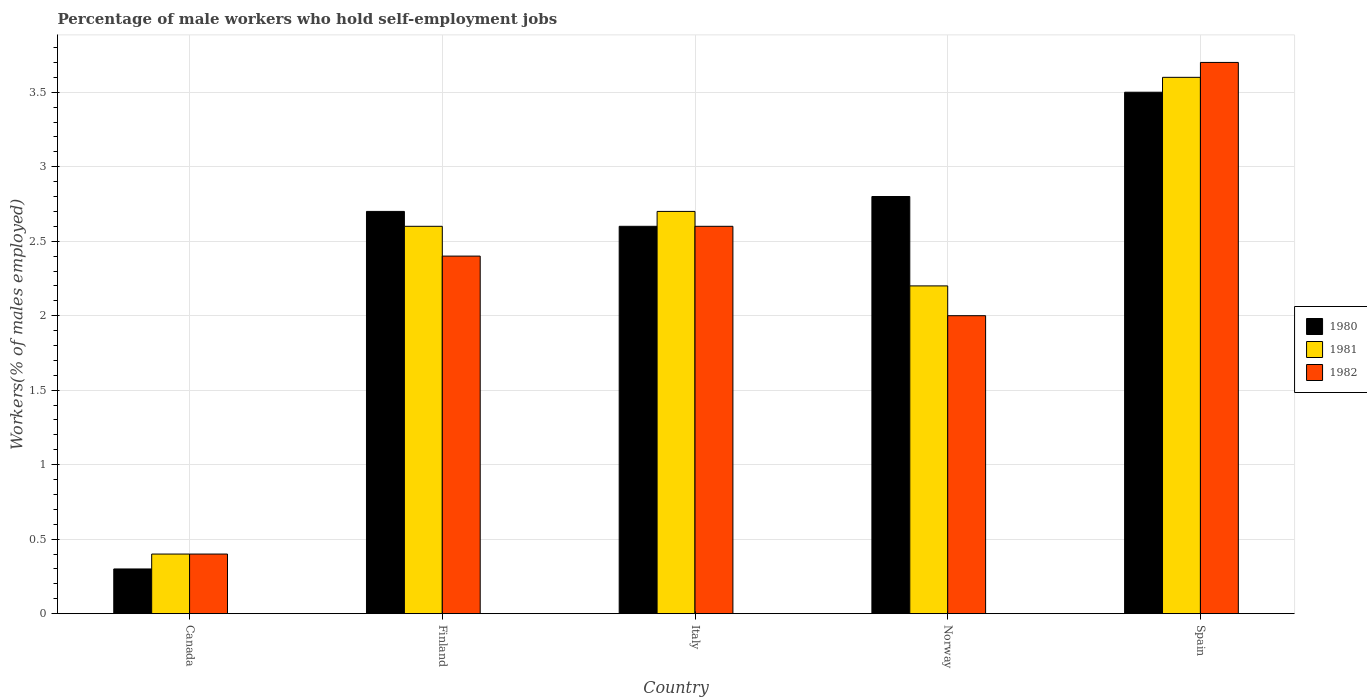How many different coloured bars are there?
Ensure brevity in your answer.  3. How many groups of bars are there?
Your answer should be very brief. 5. Are the number of bars on each tick of the X-axis equal?
Offer a very short reply. Yes. How many bars are there on the 2nd tick from the left?
Keep it short and to the point. 3. How many bars are there on the 4th tick from the right?
Your answer should be compact. 3. What is the label of the 5th group of bars from the left?
Make the answer very short. Spain. What is the percentage of self-employed male workers in 1980 in Canada?
Provide a succinct answer. 0.3. Across all countries, what is the minimum percentage of self-employed male workers in 1981?
Your answer should be very brief. 0.4. In which country was the percentage of self-employed male workers in 1981 maximum?
Your response must be concise. Spain. In which country was the percentage of self-employed male workers in 1982 minimum?
Your answer should be compact. Canada. What is the total percentage of self-employed male workers in 1980 in the graph?
Offer a terse response. 11.9. What is the difference between the percentage of self-employed male workers in 1981 in Canada and that in Finland?
Make the answer very short. -2.2. What is the difference between the percentage of self-employed male workers in 1982 in Norway and the percentage of self-employed male workers in 1981 in Finland?
Provide a succinct answer. -0.6. What is the average percentage of self-employed male workers in 1980 per country?
Keep it short and to the point. 2.38. In how many countries, is the percentage of self-employed male workers in 1981 greater than 0.7 %?
Your answer should be very brief. 4. What is the ratio of the percentage of self-employed male workers in 1981 in Canada to that in Spain?
Your answer should be very brief. 0.11. What is the difference between the highest and the second highest percentage of self-employed male workers in 1981?
Make the answer very short. -0.9. What is the difference between the highest and the lowest percentage of self-employed male workers in 1980?
Offer a very short reply. 3.2. In how many countries, is the percentage of self-employed male workers in 1982 greater than the average percentage of self-employed male workers in 1982 taken over all countries?
Provide a succinct answer. 3. What does the 2nd bar from the left in Spain represents?
Make the answer very short. 1981. What is the difference between two consecutive major ticks on the Y-axis?
Keep it short and to the point. 0.5. Are the values on the major ticks of Y-axis written in scientific E-notation?
Your answer should be very brief. No. Does the graph contain any zero values?
Your response must be concise. No. Does the graph contain grids?
Give a very brief answer. Yes. Where does the legend appear in the graph?
Provide a succinct answer. Center right. How many legend labels are there?
Your answer should be very brief. 3. What is the title of the graph?
Your response must be concise. Percentage of male workers who hold self-employment jobs. Does "2010" appear as one of the legend labels in the graph?
Provide a short and direct response. No. What is the label or title of the X-axis?
Offer a terse response. Country. What is the label or title of the Y-axis?
Offer a terse response. Workers(% of males employed). What is the Workers(% of males employed) of 1980 in Canada?
Provide a short and direct response. 0.3. What is the Workers(% of males employed) of 1981 in Canada?
Your answer should be very brief. 0.4. What is the Workers(% of males employed) in 1982 in Canada?
Offer a very short reply. 0.4. What is the Workers(% of males employed) of 1980 in Finland?
Offer a terse response. 2.7. What is the Workers(% of males employed) of 1981 in Finland?
Your answer should be very brief. 2.6. What is the Workers(% of males employed) of 1982 in Finland?
Ensure brevity in your answer.  2.4. What is the Workers(% of males employed) of 1980 in Italy?
Provide a succinct answer. 2.6. What is the Workers(% of males employed) of 1981 in Italy?
Make the answer very short. 2.7. What is the Workers(% of males employed) in 1982 in Italy?
Your answer should be very brief. 2.6. What is the Workers(% of males employed) of 1980 in Norway?
Your response must be concise. 2.8. What is the Workers(% of males employed) of 1981 in Norway?
Ensure brevity in your answer.  2.2. What is the Workers(% of males employed) of 1982 in Norway?
Offer a terse response. 2. What is the Workers(% of males employed) in 1980 in Spain?
Your answer should be very brief. 3.5. What is the Workers(% of males employed) in 1981 in Spain?
Your answer should be very brief. 3.6. What is the Workers(% of males employed) of 1982 in Spain?
Keep it short and to the point. 3.7. Across all countries, what is the maximum Workers(% of males employed) of 1981?
Keep it short and to the point. 3.6. Across all countries, what is the maximum Workers(% of males employed) of 1982?
Your response must be concise. 3.7. Across all countries, what is the minimum Workers(% of males employed) of 1980?
Give a very brief answer. 0.3. Across all countries, what is the minimum Workers(% of males employed) of 1981?
Provide a succinct answer. 0.4. Across all countries, what is the minimum Workers(% of males employed) of 1982?
Your response must be concise. 0.4. What is the total Workers(% of males employed) of 1981 in the graph?
Keep it short and to the point. 11.5. What is the difference between the Workers(% of males employed) in 1981 in Canada and that in Finland?
Your response must be concise. -2.2. What is the difference between the Workers(% of males employed) in 1982 in Canada and that in Norway?
Your answer should be very brief. -1.6. What is the difference between the Workers(% of males employed) in 1980 in Canada and that in Spain?
Give a very brief answer. -3.2. What is the difference between the Workers(% of males employed) in 1982 in Canada and that in Spain?
Offer a very short reply. -3.3. What is the difference between the Workers(% of males employed) in 1980 in Finland and that in Italy?
Give a very brief answer. 0.1. What is the difference between the Workers(% of males employed) of 1981 in Finland and that in Norway?
Your answer should be compact. 0.4. What is the difference between the Workers(% of males employed) in 1982 in Finland and that in Norway?
Your response must be concise. 0.4. What is the difference between the Workers(% of males employed) in 1980 in Finland and that in Spain?
Ensure brevity in your answer.  -0.8. What is the difference between the Workers(% of males employed) in 1981 in Finland and that in Spain?
Ensure brevity in your answer.  -1. What is the difference between the Workers(% of males employed) of 1982 in Finland and that in Spain?
Provide a short and direct response. -1.3. What is the difference between the Workers(% of males employed) in 1980 in Italy and that in Norway?
Offer a very short reply. -0.2. What is the difference between the Workers(% of males employed) of 1980 in Italy and that in Spain?
Ensure brevity in your answer.  -0.9. What is the difference between the Workers(% of males employed) in 1981 in Italy and that in Spain?
Your response must be concise. -0.9. What is the difference between the Workers(% of males employed) of 1982 in Italy and that in Spain?
Your answer should be very brief. -1.1. What is the difference between the Workers(% of males employed) in 1980 in Canada and the Workers(% of males employed) in 1981 in Finland?
Give a very brief answer. -2.3. What is the difference between the Workers(% of males employed) in 1980 in Canada and the Workers(% of males employed) in 1982 in Finland?
Your answer should be compact. -2.1. What is the difference between the Workers(% of males employed) of 1980 in Canada and the Workers(% of males employed) of 1981 in Italy?
Offer a very short reply. -2.4. What is the difference between the Workers(% of males employed) in 1981 in Canada and the Workers(% of males employed) in 1982 in Italy?
Ensure brevity in your answer.  -2.2. What is the difference between the Workers(% of males employed) of 1980 in Canada and the Workers(% of males employed) of 1981 in Norway?
Provide a short and direct response. -1.9. What is the difference between the Workers(% of males employed) of 1981 in Canada and the Workers(% of males employed) of 1982 in Norway?
Offer a terse response. -1.6. What is the difference between the Workers(% of males employed) of 1980 in Canada and the Workers(% of males employed) of 1981 in Spain?
Offer a very short reply. -3.3. What is the difference between the Workers(% of males employed) in 1981 in Canada and the Workers(% of males employed) in 1982 in Spain?
Give a very brief answer. -3.3. What is the difference between the Workers(% of males employed) in 1980 in Finland and the Workers(% of males employed) in 1982 in Italy?
Provide a succinct answer. 0.1. What is the difference between the Workers(% of males employed) of 1980 in Finland and the Workers(% of males employed) of 1981 in Norway?
Your answer should be compact. 0.5. What is the difference between the Workers(% of males employed) in 1980 in Finland and the Workers(% of males employed) in 1982 in Spain?
Ensure brevity in your answer.  -1. What is the difference between the Workers(% of males employed) of 1981 in Finland and the Workers(% of males employed) of 1982 in Spain?
Keep it short and to the point. -1.1. What is the difference between the Workers(% of males employed) of 1980 in Italy and the Workers(% of males employed) of 1981 in Norway?
Ensure brevity in your answer.  0.4. What is the difference between the Workers(% of males employed) of 1980 in Italy and the Workers(% of males employed) of 1982 in Norway?
Your answer should be very brief. 0.6. What is the difference between the Workers(% of males employed) of 1981 in Italy and the Workers(% of males employed) of 1982 in Norway?
Keep it short and to the point. 0.7. What is the difference between the Workers(% of males employed) in 1980 in Italy and the Workers(% of males employed) in 1982 in Spain?
Your response must be concise. -1.1. What is the difference between the Workers(% of males employed) of 1981 in Norway and the Workers(% of males employed) of 1982 in Spain?
Keep it short and to the point. -1.5. What is the average Workers(% of males employed) in 1980 per country?
Offer a terse response. 2.38. What is the average Workers(% of males employed) in 1982 per country?
Your answer should be compact. 2.22. What is the difference between the Workers(% of males employed) of 1980 and Workers(% of males employed) of 1981 in Canada?
Offer a very short reply. -0.1. What is the difference between the Workers(% of males employed) in 1980 and Workers(% of males employed) in 1982 in Canada?
Make the answer very short. -0.1. What is the difference between the Workers(% of males employed) in 1981 and Workers(% of males employed) in 1982 in Canada?
Ensure brevity in your answer.  0. What is the difference between the Workers(% of males employed) of 1980 and Workers(% of males employed) of 1981 in Finland?
Offer a terse response. 0.1. What is the difference between the Workers(% of males employed) in 1981 and Workers(% of males employed) in 1982 in Italy?
Ensure brevity in your answer.  0.1. What is the difference between the Workers(% of males employed) in 1980 and Workers(% of males employed) in 1981 in Norway?
Your answer should be compact. 0.6. What is the difference between the Workers(% of males employed) in 1980 and Workers(% of males employed) in 1982 in Norway?
Provide a short and direct response. 0.8. What is the difference between the Workers(% of males employed) of 1981 and Workers(% of males employed) of 1982 in Norway?
Keep it short and to the point. 0.2. What is the difference between the Workers(% of males employed) of 1980 and Workers(% of males employed) of 1981 in Spain?
Offer a very short reply. -0.1. What is the difference between the Workers(% of males employed) in 1980 and Workers(% of males employed) in 1982 in Spain?
Ensure brevity in your answer.  -0.2. What is the difference between the Workers(% of males employed) of 1981 and Workers(% of males employed) of 1982 in Spain?
Give a very brief answer. -0.1. What is the ratio of the Workers(% of males employed) of 1981 in Canada to that in Finland?
Your answer should be compact. 0.15. What is the ratio of the Workers(% of males employed) of 1982 in Canada to that in Finland?
Your answer should be very brief. 0.17. What is the ratio of the Workers(% of males employed) in 1980 in Canada to that in Italy?
Make the answer very short. 0.12. What is the ratio of the Workers(% of males employed) in 1981 in Canada to that in Italy?
Your answer should be very brief. 0.15. What is the ratio of the Workers(% of males employed) in 1982 in Canada to that in Italy?
Your answer should be compact. 0.15. What is the ratio of the Workers(% of males employed) of 1980 in Canada to that in Norway?
Provide a succinct answer. 0.11. What is the ratio of the Workers(% of males employed) of 1981 in Canada to that in Norway?
Your answer should be very brief. 0.18. What is the ratio of the Workers(% of males employed) in 1982 in Canada to that in Norway?
Make the answer very short. 0.2. What is the ratio of the Workers(% of males employed) of 1980 in Canada to that in Spain?
Offer a terse response. 0.09. What is the ratio of the Workers(% of males employed) in 1982 in Canada to that in Spain?
Give a very brief answer. 0.11. What is the ratio of the Workers(% of males employed) of 1981 in Finland to that in Italy?
Offer a terse response. 0.96. What is the ratio of the Workers(% of males employed) of 1982 in Finland to that in Italy?
Keep it short and to the point. 0.92. What is the ratio of the Workers(% of males employed) of 1981 in Finland to that in Norway?
Give a very brief answer. 1.18. What is the ratio of the Workers(% of males employed) in 1982 in Finland to that in Norway?
Provide a short and direct response. 1.2. What is the ratio of the Workers(% of males employed) in 1980 in Finland to that in Spain?
Provide a succinct answer. 0.77. What is the ratio of the Workers(% of males employed) of 1981 in Finland to that in Spain?
Your answer should be very brief. 0.72. What is the ratio of the Workers(% of males employed) of 1982 in Finland to that in Spain?
Provide a short and direct response. 0.65. What is the ratio of the Workers(% of males employed) in 1980 in Italy to that in Norway?
Your answer should be compact. 0.93. What is the ratio of the Workers(% of males employed) in 1981 in Italy to that in Norway?
Your answer should be compact. 1.23. What is the ratio of the Workers(% of males employed) of 1982 in Italy to that in Norway?
Offer a very short reply. 1.3. What is the ratio of the Workers(% of males employed) of 1980 in Italy to that in Spain?
Your answer should be compact. 0.74. What is the ratio of the Workers(% of males employed) in 1981 in Italy to that in Spain?
Offer a terse response. 0.75. What is the ratio of the Workers(% of males employed) in 1982 in Italy to that in Spain?
Make the answer very short. 0.7. What is the ratio of the Workers(% of males employed) of 1980 in Norway to that in Spain?
Ensure brevity in your answer.  0.8. What is the ratio of the Workers(% of males employed) of 1981 in Norway to that in Spain?
Provide a succinct answer. 0.61. What is the ratio of the Workers(% of males employed) of 1982 in Norway to that in Spain?
Offer a terse response. 0.54. What is the difference between the highest and the second highest Workers(% of males employed) of 1980?
Your answer should be very brief. 0.7. What is the difference between the highest and the second highest Workers(% of males employed) in 1981?
Your response must be concise. 0.9. What is the difference between the highest and the lowest Workers(% of males employed) in 1980?
Provide a short and direct response. 3.2. What is the difference between the highest and the lowest Workers(% of males employed) in 1981?
Keep it short and to the point. 3.2. What is the difference between the highest and the lowest Workers(% of males employed) in 1982?
Give a very brief answer. 3.3. 